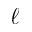Convert formula to latex. <formula><loc_0><loc_0><loc_500><loc_500>\ell</formula> 